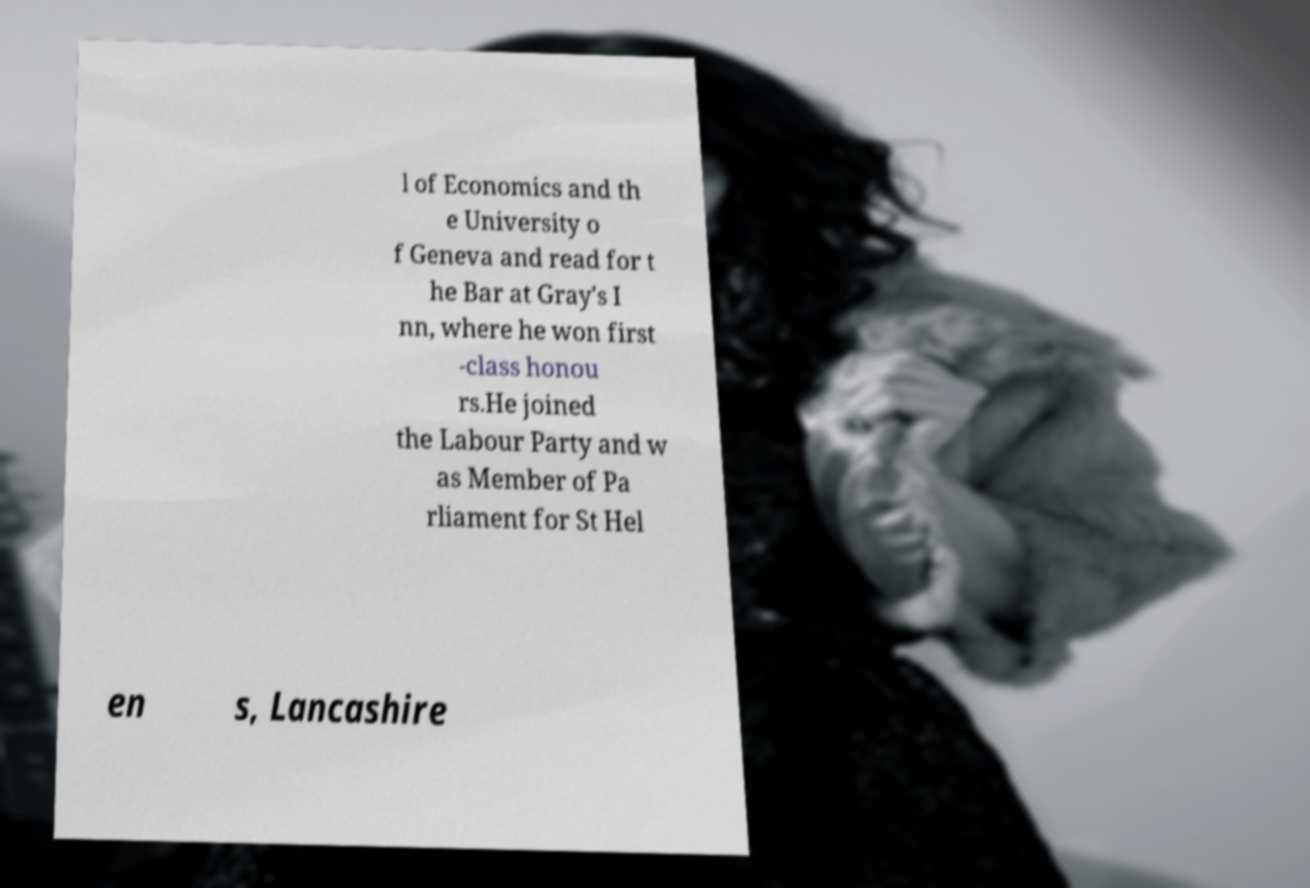Could you assist in decoding the text presented in this image and type it out clearly? l of Economics and th e University o f Geneva and read for t he Bar at Gray's I nn, where he won first -class honou rs.He joined the Labour Party and w as Member of Pa rliament for St Hel en s, Lancashire 